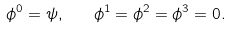Convert formula to latex. <formula><loc_0><loc_0><loc_500><loc_500>\phi ^ { 0 } = \psi , \quad \phi ^ { 1 } = \phi ^ { 2 } = \phi ^ { 3 } = 0 .</formula> 